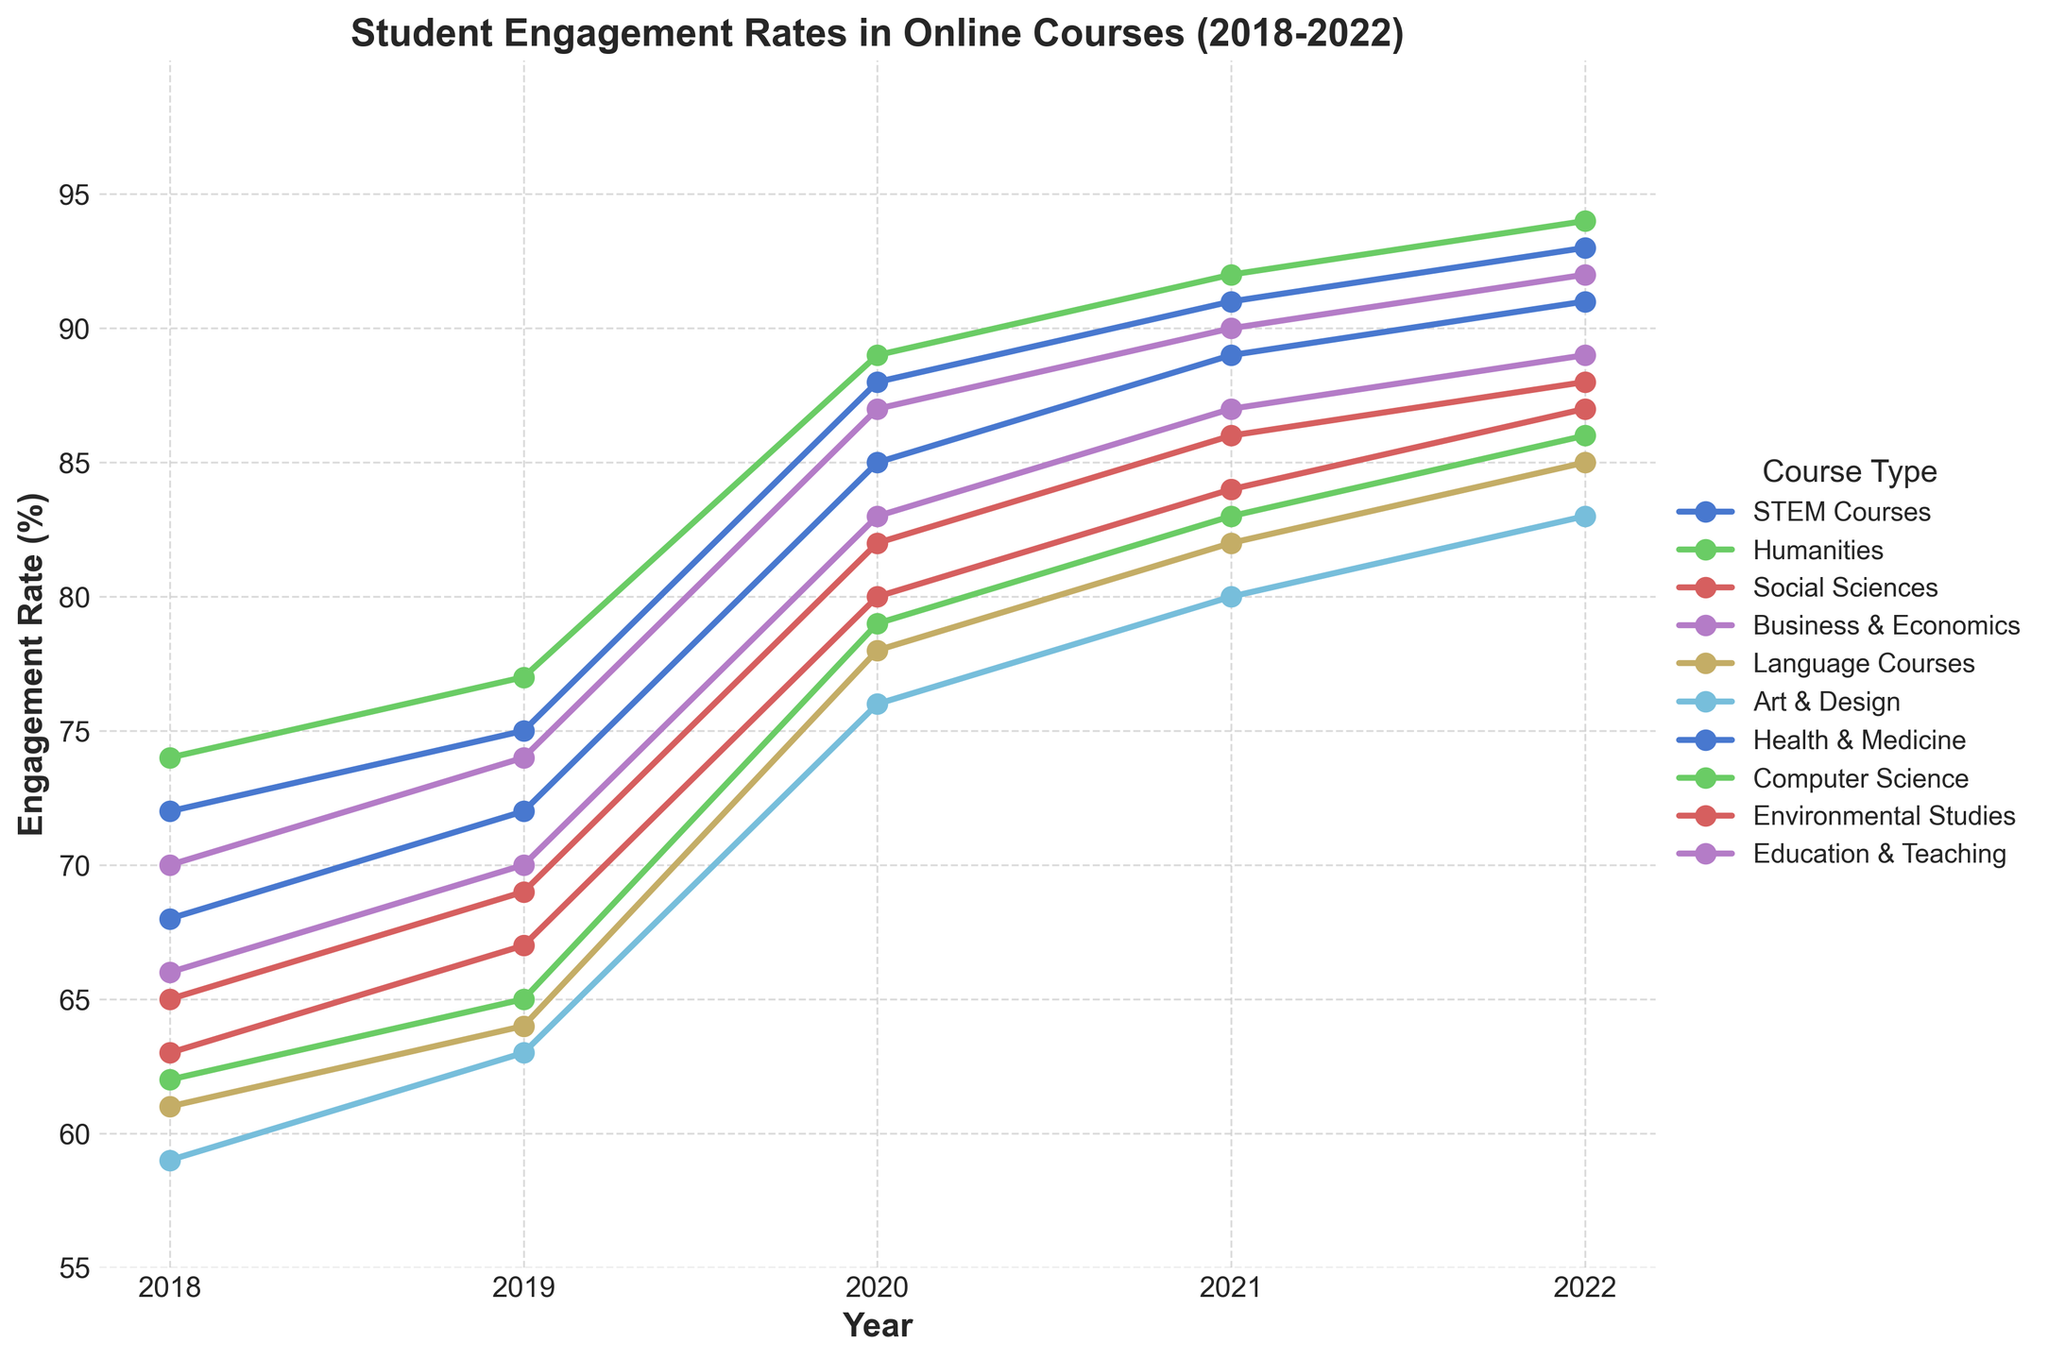What course type had the highest student engagement rate in 2022? Look for the highest data point in the year 2022 and identify the corresponding course type. The highest point in 2022 is 94, which corresponds to Computer Science.
Answer: Computer Science Which course type showed the greatest increase in student engagement rate from 2018 to 2022? Calculate the difference in engagement rates for each course type between 2018 and 2022, and identify the course type with the largest increase. For Computer Science, the increase is 94 - 74 = 20, which is the highest.
Answer: Computer Science What was the average student engagement rate across all course types in 2020? Sum the engagement rates for all course types in 2020 and divide by the number of course types. (85 + 79 + 82 + 87 + 78 + 76 + 88 + 89 + 80 + 83) / 10 = 82.7
Answer: 82.7 Did any course types have the same engagement rate in any year? Visually inspect the chart for overlapping points. In 2019, Computer Science and Health & Medicine both have an engagement rate of 75.
Answer: Yes, in 2019 for Computer Science and Health & Medicine Between STEM Courses and Business & Economics, which had higher student engagement rates across all years? Compare the engagement rates for each year for the two course types and count how many times each has a higher rate. Business & Economics had higher rates in 2018, 2019, 2020, 2021, and 2022.
Answer: Business & Economics Which course type had the lowest engagement rate in 2018? Find the minimum data point for the year 2018 and identify the corresponding course type. The lowest point in 2018 is 59, which corresponds to Art & Design.
Answer: Art & Design How did the engagement rates for Humanities and Language Courses compare in 2021? Look at the rates for Humanities and Language Courses in 2021, which are 83 and 82 respectively. Humanities has a slightly higher rate.
Answer: Humanities What is the range of engagement rates (difference between maximum and minimum rates) in 2022? Identify the maximum and minimum engagement rates in 2022 and subtract the minimum from the maximum. The maximum is 94 and the minimum is 83, so the range is 94 - 83 = 11.
Answer: 11 Which course type had the most consistent engagement rate increase, i.e., the least variation, from 2018 to 2022? Visually inspect the chart and identify the line that has the most consistent upward trend without significant fluctuations. STEM Courses has a fairly consistent trend with small and steady increments each year.
Answer: STEM Courses 